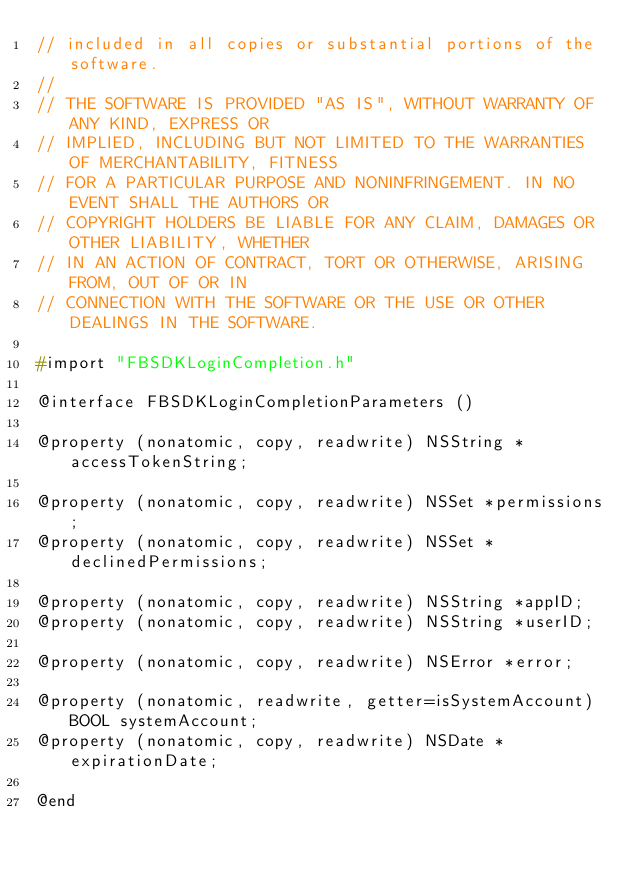<code> <loc_0><loc_0><loc_500><loc_500><_C_>// included in all copies or substantial portions of the software.
//
// THE SOFTWARE IS PROVIDED "AS IS", WITHOUT WARRANTY OF ANY KIND, EXPRESS OR
// IMPLIED, INCLUDING BUT NOT LIMITED TO THE WARRANTIES OF MERCHANTABILITY, FITNESS
// FOR A PARTICULAR PURPOSE AND NONINFRINGEMENT. IN NO EVENT SHALL THE AUTHORS OR
// COPYRIGHT HOLDERS BE LIABLE FOR ANY CLAIM, DAMAGES OR OTHER LIABILITY, WHETHER
// IN AN ACTION OF CONTRACT, TORT OR OTHERWISE, ARISING FROM, OUT OF OR IN
// CONNECTION WITH THE SOFTWARE OR THE USE OR OTHER DEALINGS IN THE SOFTWARE.

#import "FBSDKLoginCompletion.h"

@interface FBSDKLoginCompletionParameters ()

@property (nonatomic, copy, readwrite) NSString *accessTokenString;

@property (nonatomic, copy, readwrite) NSSet *permissions;
@property (nonatomic, copy, readwrite) NSSet *declinedPermissions;

@property (nonatomic, copy, readwrite) NSString *appID;
@property (nonatomic, copy, readwrite) NSString *userID;

@property (nonatomic, copy, readwrite) NSError *error;

@property (nonatomic, readwrite, getter=isSystemAccount) BOOL systemAccount;
@property (nonatomic, copy, readwrite) NSDate *expirationDate;

@end
</code> 